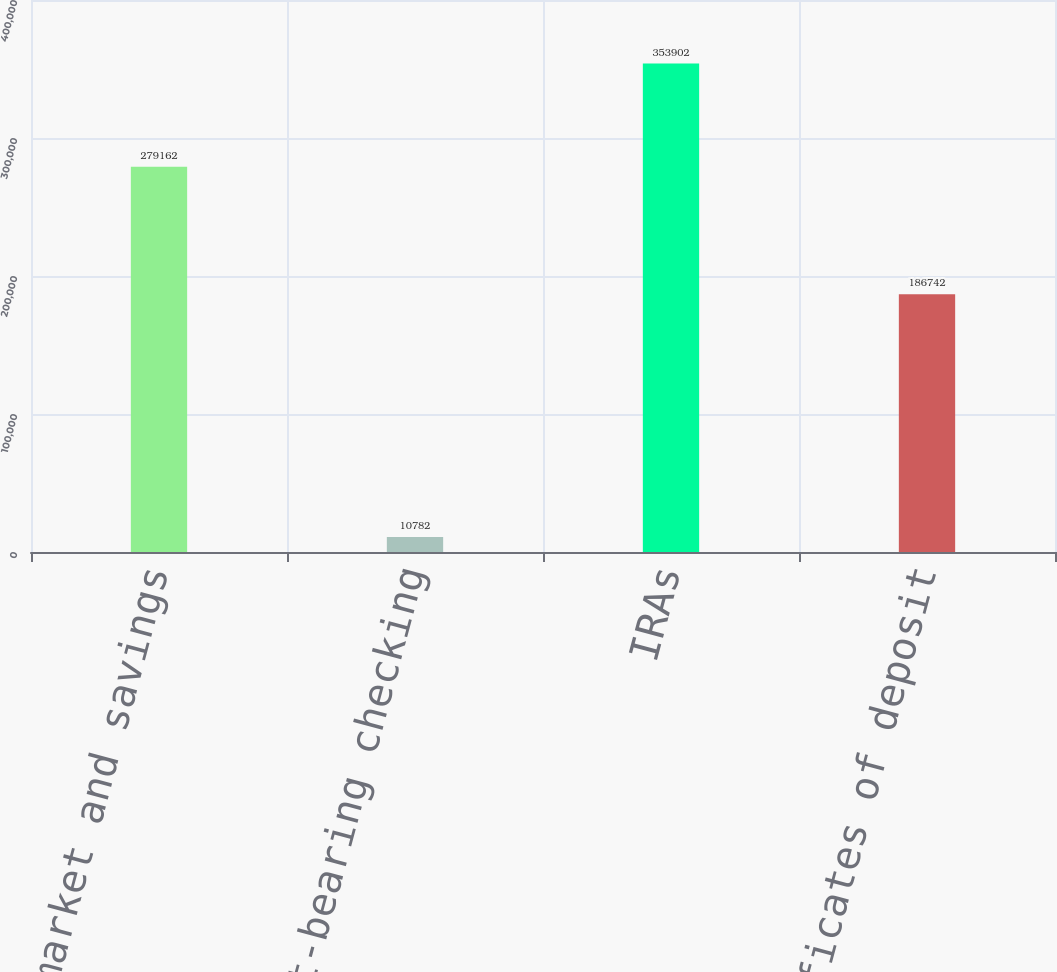Convert chart to OTSL. <chart><loc_0><loc_0><loc_500><loc_500><bar_chart><fcel>Money market and savings<fcel>Interest-bearing checking<fcel>IRAs<fcel>Certificates of deposit<nl><fcel>279162<fcel>10782<fcel>353902<fcel>186742<nl></chart> 